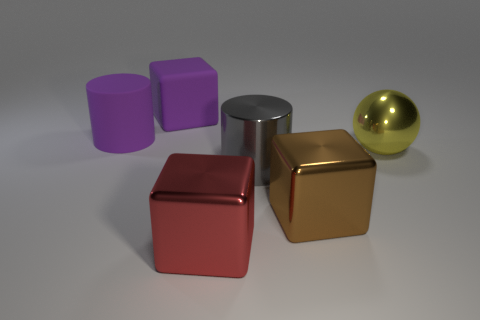Add 2 large cyan metallic cubes. How many objects exist? 8 Subtract all cylinders. How many objects are left? 4 Subtract all big purple matte cylinders. Subtract all big red cubes. How many objects are left? 4 Add 6 big red metal blocks. How many big red metal blocks are left? 7 Add 2 gray matte cylinders. How many gray matte cylinders exist? 2 Subtract 0 gray blocks. How many objects are left? 6 